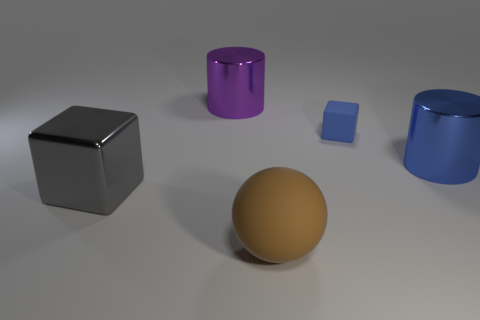What shape is the thing that is the same color as the small block?
Make the answer very short. Cylinder. There is a object that is both in front of the tiny blue rubber object and on the right side of the big brown ball; what is it made of?
Offer a terse response. Metal. Is the number of objects to the right of the purple cylinder less than the number of things that are to the right of the gray block?
Offer a terse response. Yes. There is a blue cube that is the same material as the large ball; what is its size?
Provide a short and direct response. Small. Is there any other thing that has the same color as the matte sphere?
Provide a short and direct response. No. Do the small blue object and the cube that is to the left of the big brown matte sphere have the same material?
Ensure brevity in your answer.  No. There is a big purple object that is the same shape as the blue shiny object; what material is it?
Your response must be concise. Metal. Does the block that is behind the large metal block have the same material as the large object in front of the gray thing?
Provide a short and direct response. Yes. There is a shiny object that is in front of the large metal thing on the right side of the rubber object behind the gray thing; what color is it?
Your answer should be compact. Gray. What number of other objects are there of the same shape as the gray object?
Give a very brief answer. 1. 